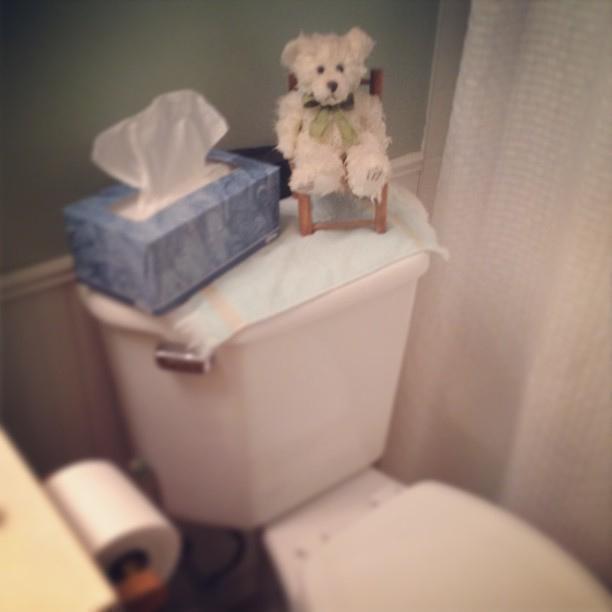How many toilets are visible?
Give a very brief answer. 1. How many people can you see?
Give a very brief answer. 0. 